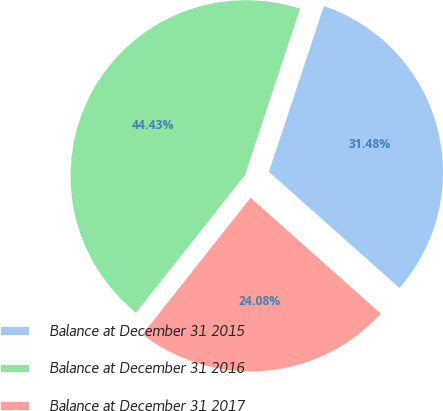<chart> <loc_0><loc_0><loc_500><loc_500><pie_chart><fcel>Balance at December 31 2015<fcel>Balance at December 31 2016<fcel>Balance at December 31 2017<nl><fcel>31.48%<fcel>44.43%<fcel>24.08%<nl></chart> 